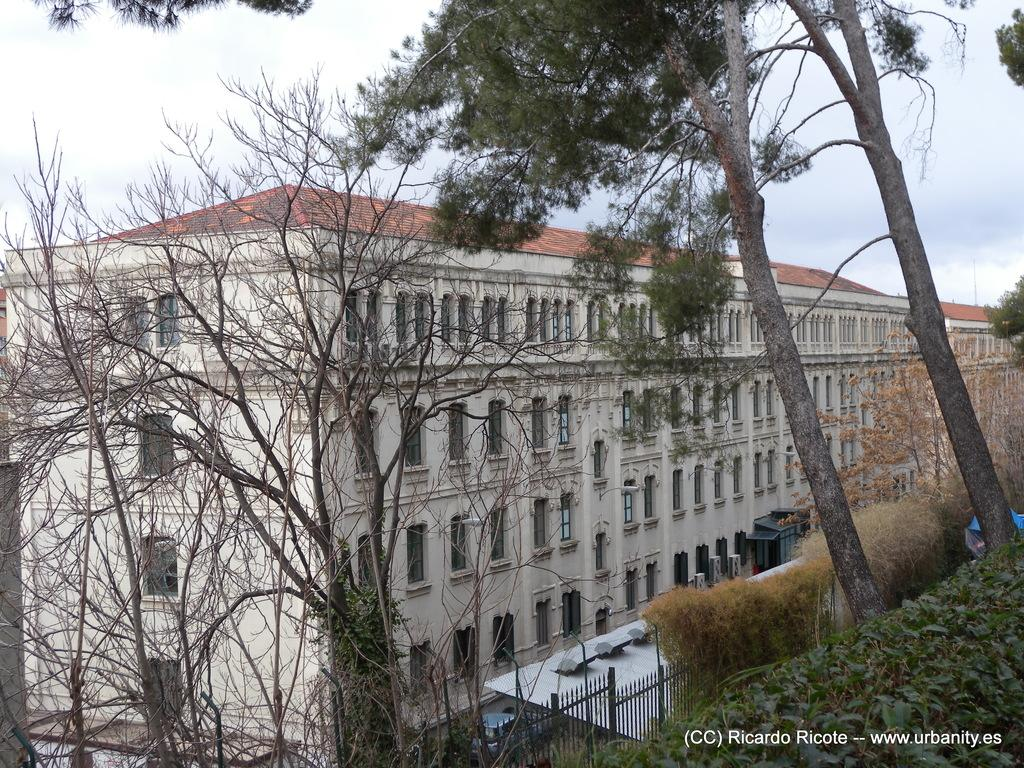What type of natural elements can be seen in the image? There are trees and plants in the image. What type of man-made structures are present in the image? There are buildings in the image. What type of barrier can be seen in the image? There is a fence in the image. What other objects can be seen in the image? There are other objects in the image, but their specific details are not mentioned in the provided facts. What is visible in the background of the image? The sky is visible in the background of the image. Is there any text or marking on the image? Yes, there is a watermark in the bottom right corner of the image. How much sugar is present in the image? There is no mention of sugar in the image, so it cannot be determined from the provided facts. What type of yoke is being used by the police in the image? There is no mention of police or yokes in the image, so it cannot be determined from the provided facts. 